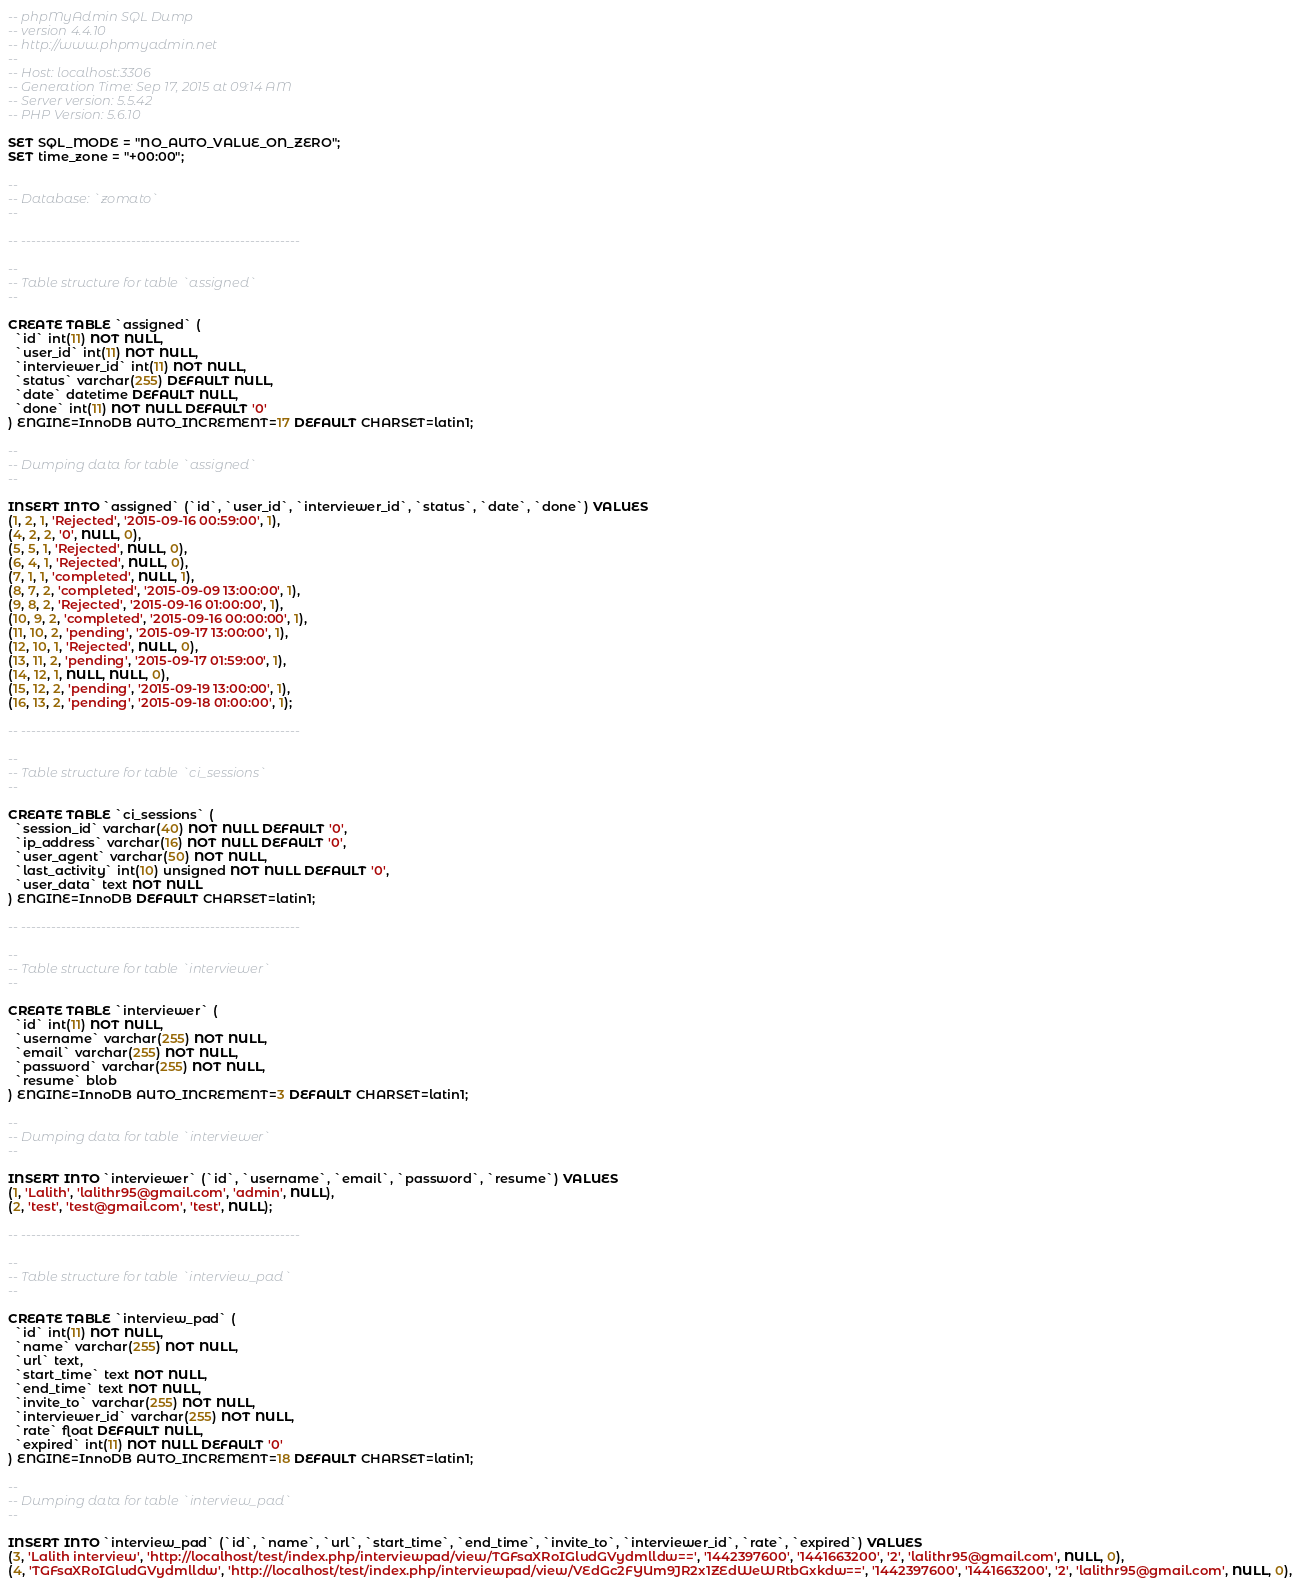Convert code to text. <code><loc_0><loc_0><loc_500><loc_500><_SQL_>-- phpMyAdmin SQL Dump
-- version 4.4.10
-- http://www.phpmyadmin.net
--
-- Host: localhost:3306
-- Generation Time: Sep 17, 2015 at 09:14 AM
-- Server version: 5.5.42
-- PHP Version: 5.6.10

SET SQL_MODE = "NO_AUTO_VALUE_ON_ZERO";
SET time_zone = "+00:00";

--
-- Database: `zomato`
--

-- --------------------------------------------------------

--
-- Table structure for table `assigned`
--

CREATE TABLE `assigned` (
  `id` int(11) NOT NULL,
  `user_id` int(11) NOT NULL,
  `interviewer_id` int(11) NOT NULL,
  `status` varchar(255) DEFAULT NULL,
  `date` datetime DEFAULT NULL,
  `done` int(11) NOT NULL DEFAULT '0'
) ENGINE=InnoDB AUTO_INCREMENT=17 DEFAULT CHARSET=latin1;

--
-- Dumping data for table `assigned`
--

INSERT INTO `assigned` (`id`, `user_id`, `interviewer_id`, `status`, `date`, `done`) VALUES
(1, 2, 1, 'Rejected', '2015-09-16 00:59:00', 1),
(4, 2, 2, '0', NULL, 0),
(5, 5, 1, 'Rejected', NULL, 0),
(6, 4, 1, 'Rejected', NULL, 0),
(7, 1, 1, 'completed', NULL, 1),
(8, 7, 2, 'completed', '2015-09-09 13:00:00', 1),
(9, 8, 2, 'Rejected', '2015-09-16 01:00:00', 1),
(10, 9, 2, 'completed', '2015-09-16 00:00:00', 1),
(11, 10, 2, 'pending', '2015-09-17 13:00:00', 1),
(12, 10, 1, 'Rejected', NULL, 0),
(13, 11, 2, 'pending', '2015-09-17 01:59:00', 1),
(14, 12, 1, NULL, NULL, 0),
(15, 12, 2, 'pending', '2015-09-19 13:00:00', 1),
(16, 13, 2, 'pending', '2015-09-18 01:00:00', 1);

-- --------------------------------------------------------

--
-- Table structure for table `ci_sessions`
--

CREATE TABLE `ci_sessions` (
  `session_id` varchar(40) NOT NULL DEFAULT '0',
  `ip_address` varchar(16) NOT NULL DEFAULT '0',
  `user_agent` varchar(50) NOT NULL,
  `last_activity` int(10) unsigned NOT NULL DEFAULT '0',
  `user_data` text NOT NULL
) ENGINE=InnoDB DEFAULT CHARSET=latin1;

-- --------------------------------------------------------

--
-- Table structure for table `interviewer`
--

CREATE TABLE `interviewer` (
  `id` int(11) NOT NULL,
  `username` varchar(255) NOT NULL,
  `email` varchar(255) NOT NULL,
  `password` varchar(255) NOT NULL,
  `resume` blob
) ENGINE=InnoDB AUTO_INCREMENT=3 DEFAULT CHARSET=latin1;

--
-- Dumping data for table `interviewer`
--

INSERT INTO `interviewer` (`id`, `username`, `email`, `password`, `resume`) VALUES
(1, 'Lalith', 'lalithr95@gmail.com', 'admin', NULL),
(2, 'test', 'test@gmail.com', 'test', NULL);

-- --------------------------------------------------------

--
-- Table structure for table `interview_pad`
--

CREATE TABLE `interview_pad` (
  `id` int(11) NOT NULL,
  `name` varchar(255) NOT NULL,
  `url` text,
  `start_time` text NOT NULL,
  `end_time` text NOT NULL,
  `invite_to` varchar(255) NOT NULL,
  `interviewer_id` varchar(255) NOT NULL,
  `rate` float DEFAULT NULL,
  `expired` int(11) NOT NULL DEFAULT '0'
) ENGINE=InnoDB AUTO_INCREMENT=18 DEFAULT CHARSET=latin1;

--
-- Dumping data for table `interview_pad`
--

INSERT INTO `interview_pad` (`id`, `name`, `url`, `start_time`, `end_time`, `invite_to`, `interviewer_id`, `rate`, `expired`) VALUES
(3, 'Lalith interview', 'http://localhost/test/index.php/interviewpad/view/TGFsaXRoIGludGVydmlldw==', '1442397600', '1441663200', '2', 'lalithr95@gmail.com', NULL, 0),
(4, 'TGFsaXRoIGludGVydmlldw', 'http://localhost/test/index.php/interviewpad/view/VEdGc2FYUm9JR2x1ZEdWeWRtbGxkdw==', '1442397600', '1441663200', '2', 'lalithr95@gmail.com', NULL, 0),</code> 